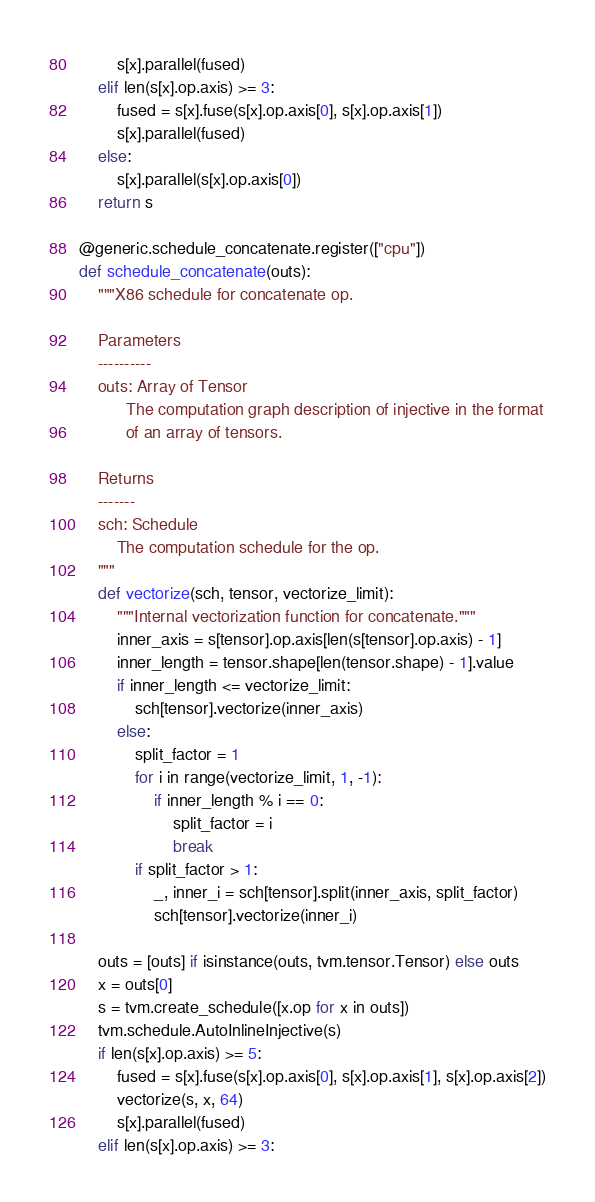<code> <loc_0><loc_0><loc_500><loc_500><_Python_>        s[x].parallel(fused)
    elif len(s[x].op.axis) >= 3:
        fused = s[x].fuse(s[x].op.axis[0], s[x].op.axis[1])
        s[x].parallel(fused)
    else:
        s[x].parallel(s[x].op.axis[0])
    return s

@generic.schedule_concatenate.register(["cpu"])
def schedule_concatenate(outs):
    """X86 schedule for concatenate op.

    Parameters
    ----------
    outs: Array of Tensor
          The computation graph description of injective in the format
          of an array of tensors.

    Returns
    -------
    sch: Schedule
        The computation schedule for the op.
    """
    def vectorize(sch, tensor, vectorize_limit):
        """Internal vectorization function for concatenate."""
        inner_axis = s[tensor].op.axis[len(s[tensor].op.axis) - 1]
        inner_length = tensor.shape[len(tensor.shape) - 1].value
        if inner_length <= vectorize_limit:
            sch[tensor].vectorize(inner_axis)
        else:
            split_factor = 1
            for i in range(vectorize_limit, 1, -1):
                if inner_length % i == 0:
                    split_factor = i
                    break
            if split_factor > 1:
                _, inner_i = sch[tensor].split(inner_axis, split_factor)
                sch[tensor].vectorize(inner_i)

    outs = [outs] if isinstance(outs, tvm.tensor.Tensor) else outs
    x = outs[0]
    s = tvm.create_schedule([x.op for x in outs])
    tvm.schedule.AutoInlineInjective(s)
    if len(s[x].op.axis) >= 5:
        fused = s[x].fuse(s[x].op.axis[0], s[x].op.axis[1], s[x].op.axis[2])
        vectorize(s, x, 64)
        s[x].parallel(fused)
    elif len(s[x].op.axis) >= 3:</code> 